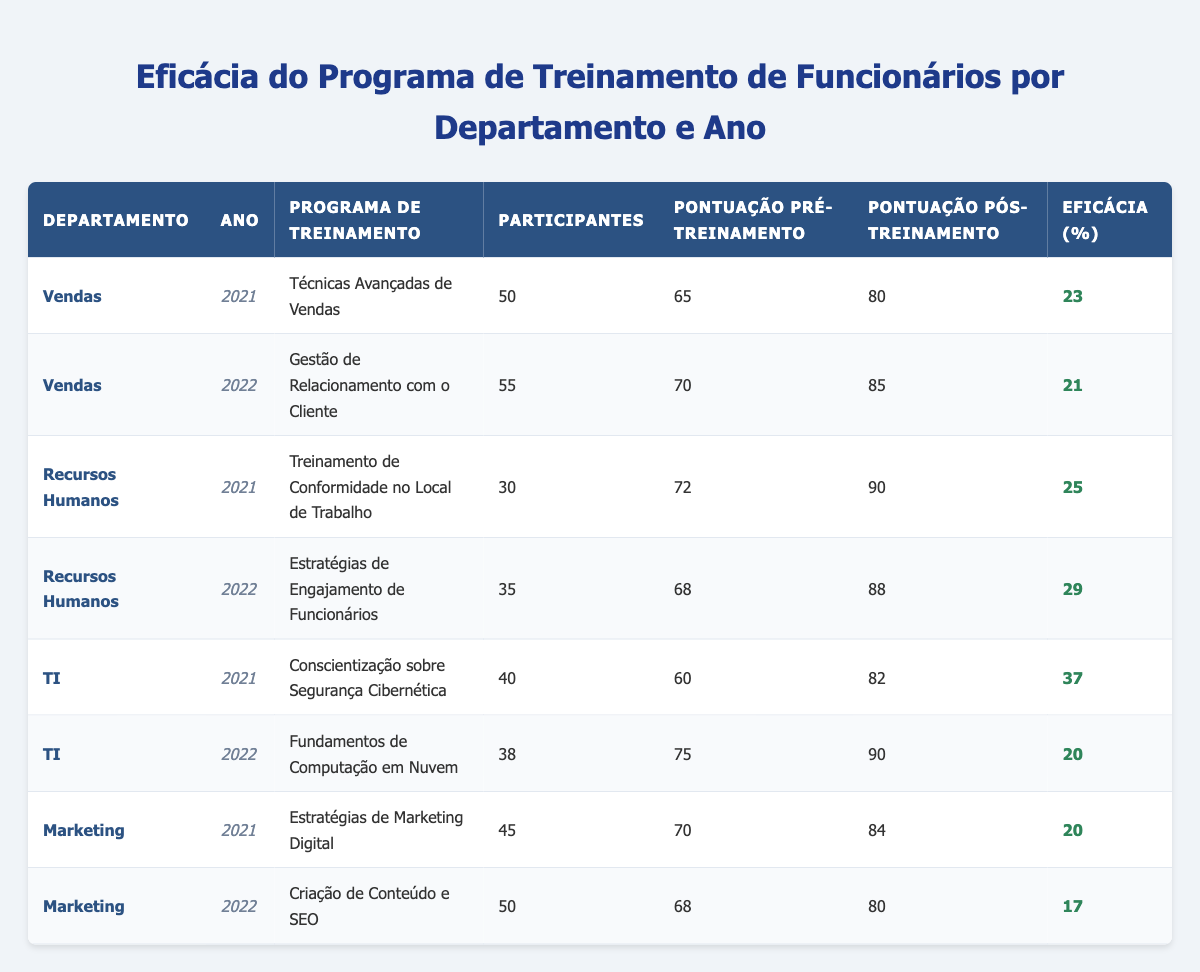What was the effectiveness percentage of the "Advanced Sales Techniques" program in 2021? The program "Advanced Sales Techniques" belongs to the Sales department for the year 2021. Looking at the table, the effectiveness percentage for this training is listed as 23.
Answer: 23 Which department had the highest effectiveness score in 2021? In 2021, the effectiveness percentages are: Sales 23, Human Resources 25, IT 37, and Marketing 20. Comparing these values, IT has the highest effectiveness score at 37.
Answer: IT What is the average effectiveness of Employee Training Programs in 2022 across all departments? The effectiveness scores for the year 2022 are: Sales 21, Human Resources 29, IT 20, and Marketing 17. Adding these scores gives (21 + 29 + 20 + 17) = 87. There are 4 programs, so the average is 87/4 = 21.75.
Answer: 21.75 Did the "Cloud Computing Fundamentals" program have a higher effectiveness than the "Digital Marketing Strategies" program? For "Cloud Computing Fundamentals" in 2022, the effectiveness is 20. For "Digital Marketing Strategies" in 2021, the effectiveness is 20 as well. Since both values are equal, the statement is false.
Answer: No Which training program in the Human Resources department had the greatest improvement in scores between pre-training and post-training? The two programs in the Human Resources department are: "Workplace Compliance Training" with a pre-training score of 72 and a post-training score of 90, leading to an improvement of (90 - 72) = 18. The second program, "Employee Engagement Strategies," has a pre-training score of 68 and a post-training score of 88, resulting in an improvement of (88 - 68) = 20. The greater improvement is from "Employee Engagement Strategies."
Answer: Employee Engagement Strategies 